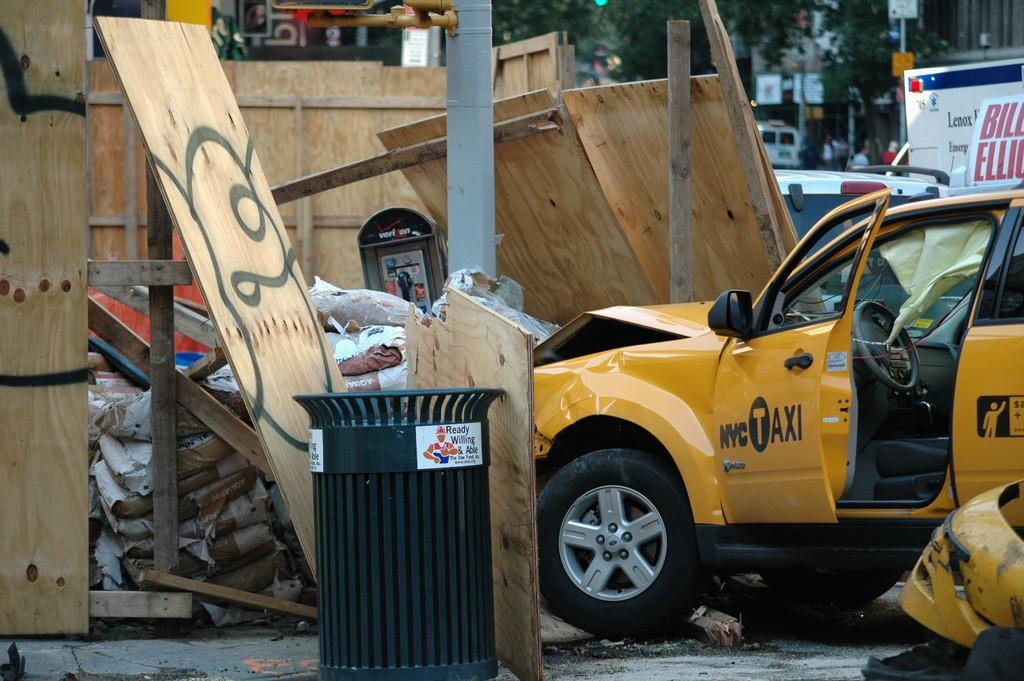Provide a one-sentence caption for the provided image. A NYC taxi has crashed into a wall and some trash. 